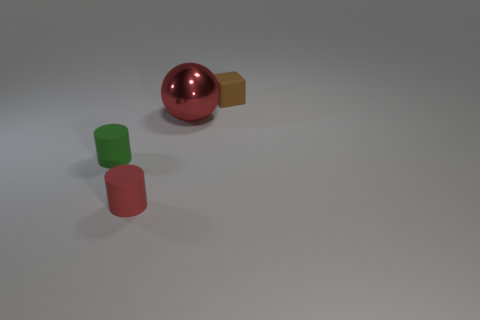Add 4 big yellow shiny balls. How many objects exist? 8 Subtract all cubes. How many objects are left? 3 Subtract all blue balls. Subtract all gray cylinders. How many balls are left? 1 Subtract all gray balls. How many red cylinders are left? 1 Subtract all tiny blocks. Subtract all rubber cubes. How many objects are left? 2 Add 2 big red metallic spheres. How many big red metallic spheres are left? 3 Add 3 tiny red rubber cylinders. How many tiny red rubber cylinders exist? 4 Subtract 1 brown blocks. How many objects are left? 3 Subtract 1 blocks. How many blocks are left? 0 